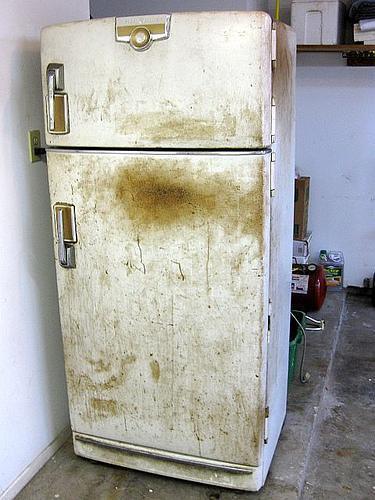How many refrigerators are there?
Give a very brief answer. 1. 